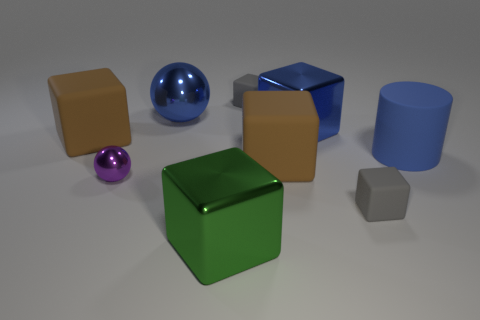Is the number of blue balls that are in front of the big cylinder the same as the number of metallic blocks?
Ensure brevity in your answer.  No. There is a blue metal thing that is the same size as the blue shiny cube; what shape is it?
Give a very brief answer. Sphere. There is a tiny block behind the blue rubber cylinder; is there a big cube to the right of it?
Provide a short and direct response. Yes. What number of small things are either cyan spheres or blue metal balls?
Offer a very short reply. 0. Is there another object of the same size as the green thing?
Make the answer very short. Yes. How many rubber things are either gray objects or tiny purple balls?
Keep it short and to the point. 2. The big matte thing that is the same color as the big shiny sphere is what shape?
Provide a short and direct response. Cylinder. How many blue spheres are there?
Offer a very short reply. 1. Are the large brown thing that is left of the large green object and the large object that is in front of the tiny purple ball made of the same material?
Keep it short and to the point. No. What is the size of the purple sphere that is made of the same material as the blue ball?
Your answer should be compact. Small. 